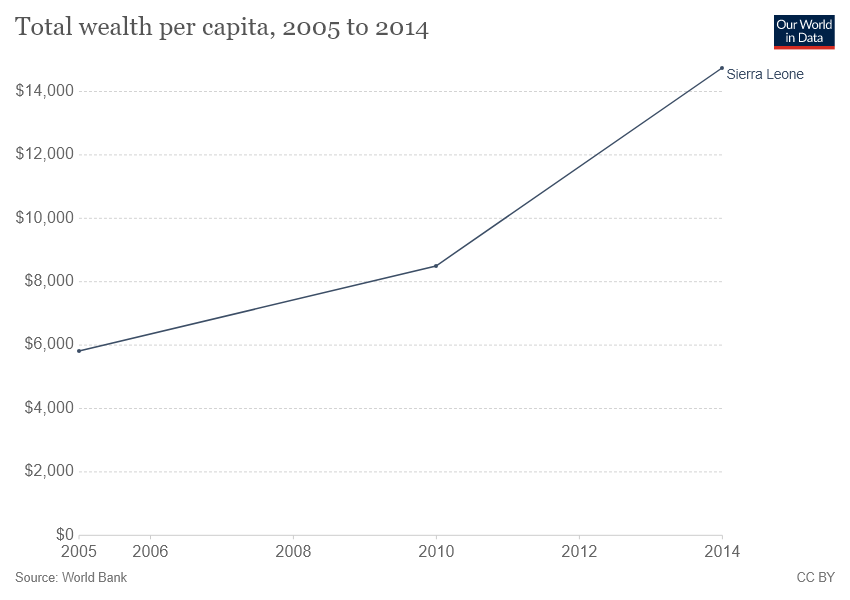Outline some significant characteristics in this image. The given line graph represents a country, and the correct answer is Sierra Leone. In approximately three years, the per capita income is expected to exceed $8,000. 